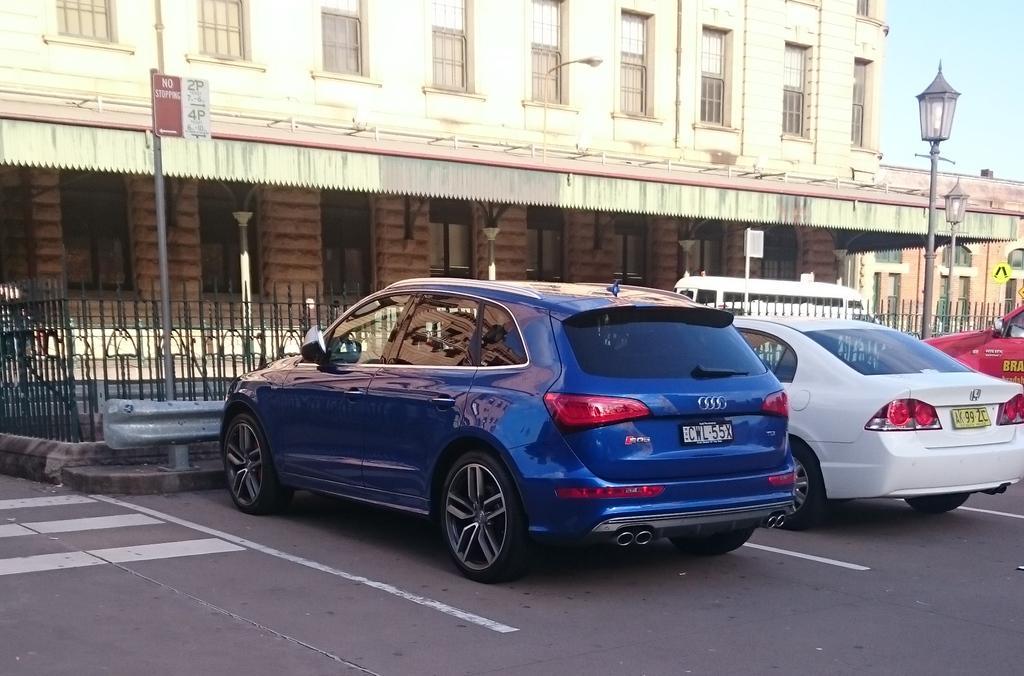How would you summarize this image in a sentence or two? Here we can see vehicles on the road and there are small boards on the poles and two light poles. In the background we can see a vehicle on the road,building,windows,roof,pillars and sky. 